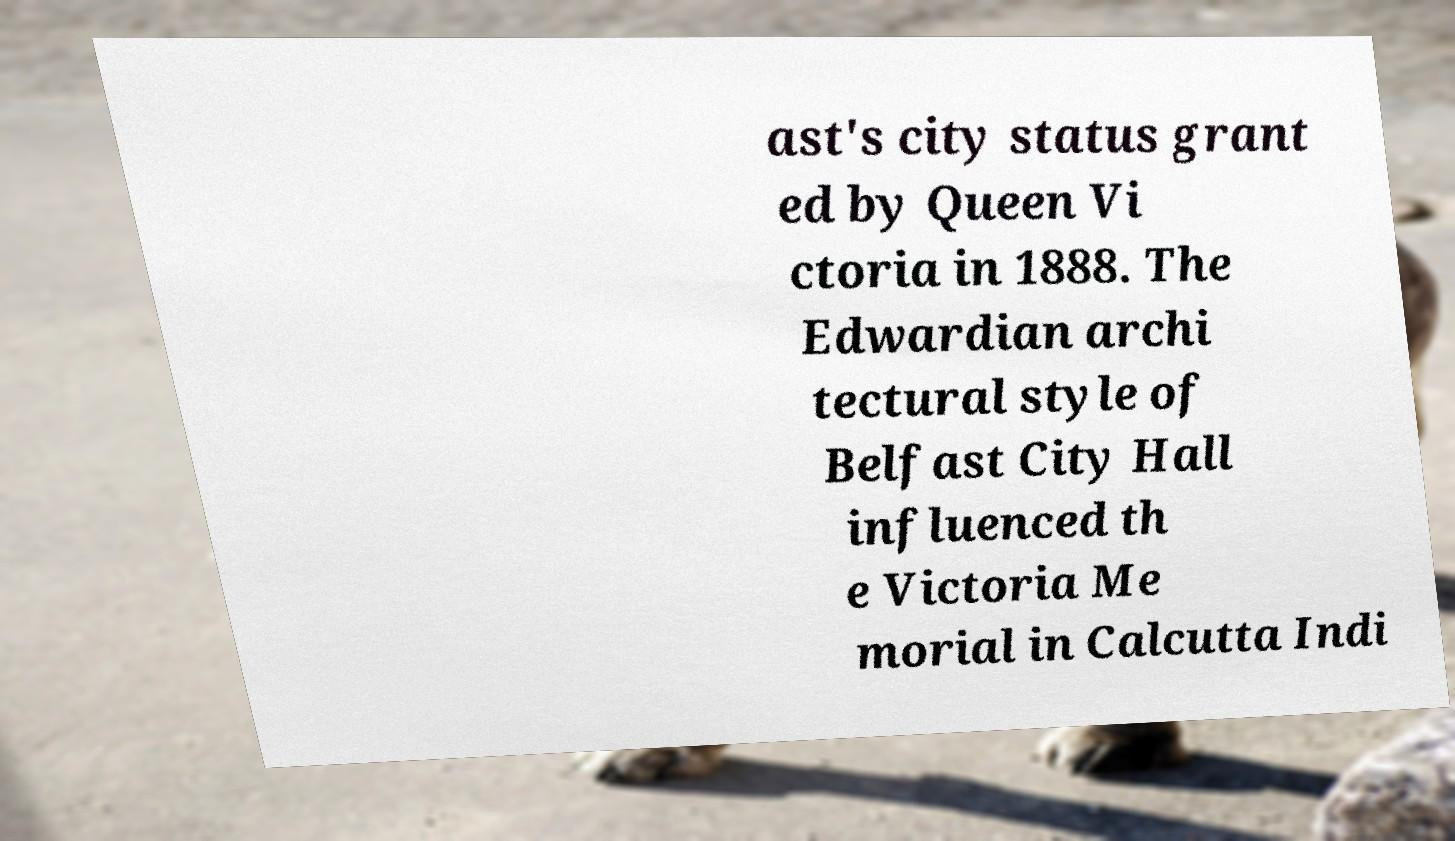What messages or text are displayed in this image? I need them in a readable, typed format. ast's city status grant ed by Queen Vi ctoria in 1888. The Edwardian archi tectural style of Belfast City Hall influenced th e Victoria Me morial in Calcutta Indi 